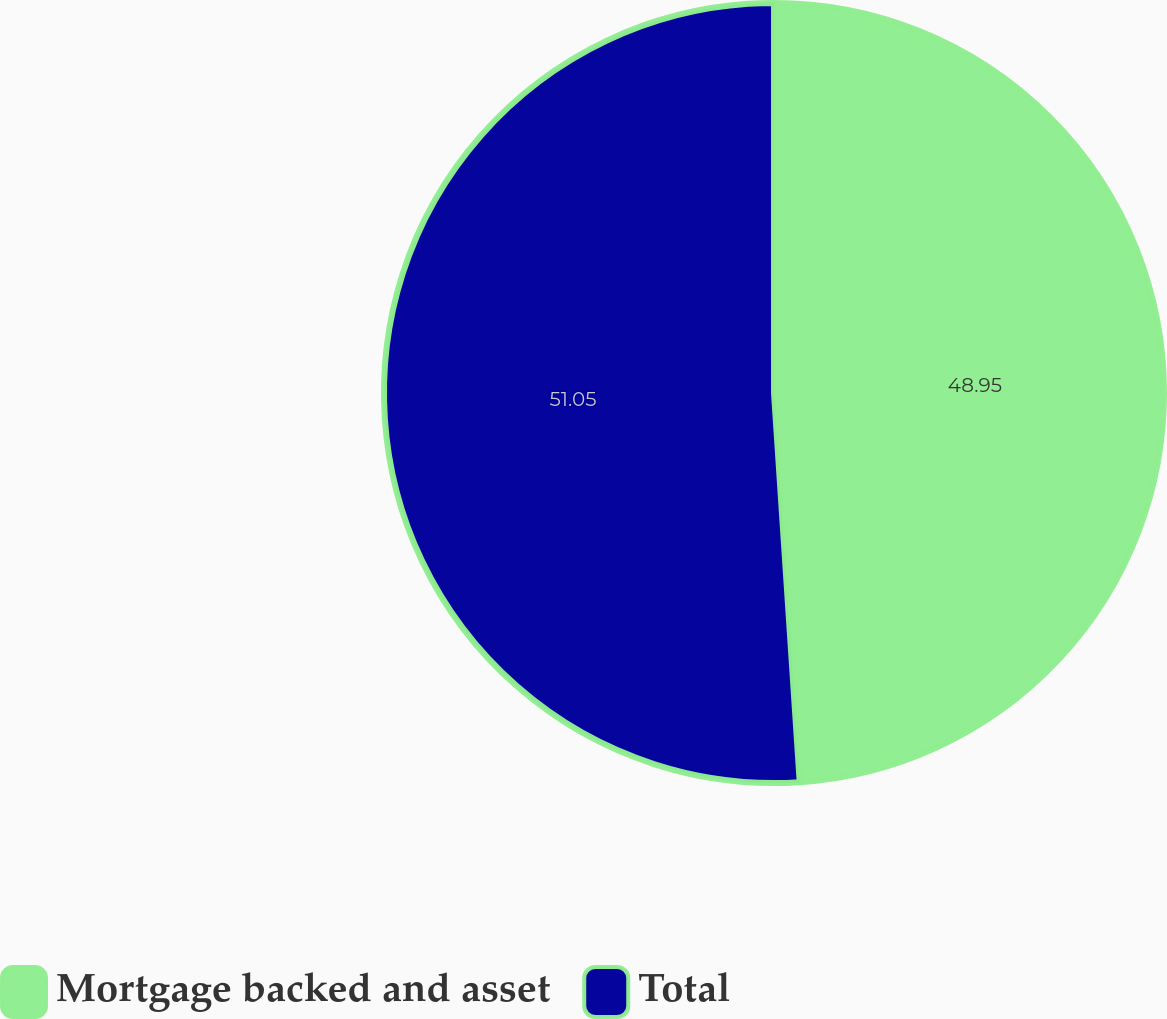<chart> <loc_0><loc_0><loc_500><loc_500><pie_chart><fcel>Mortgage backed and asset<fcel>Total<nl><fcel>48.95%<fcel>51.05%<nl></chart> 